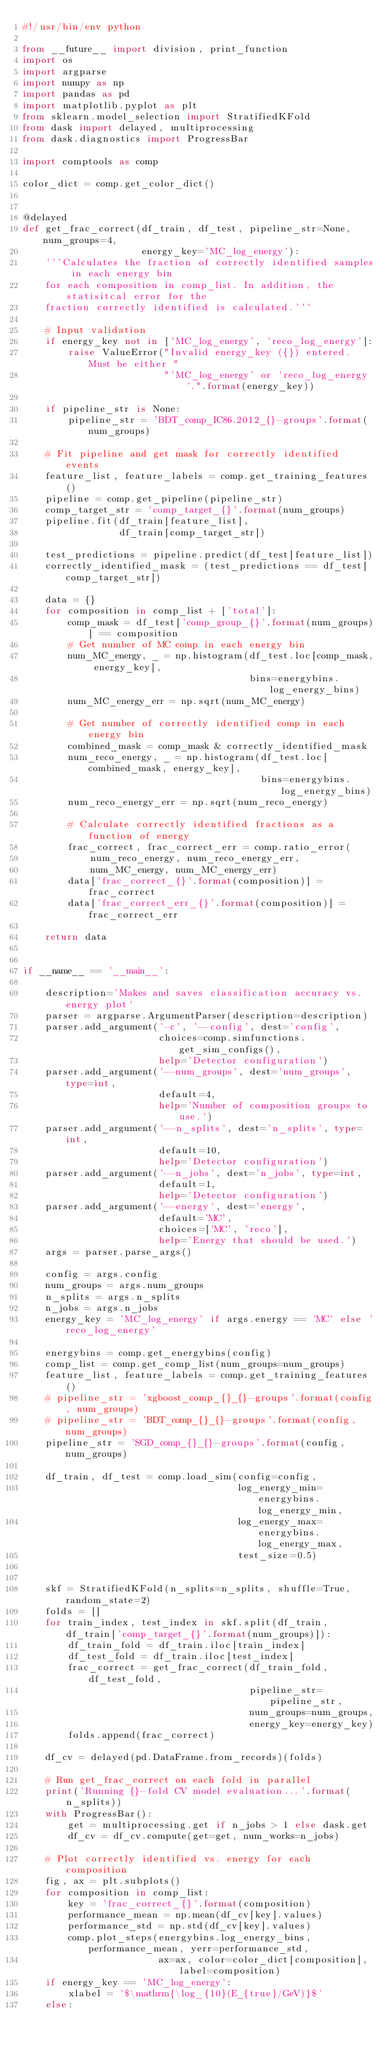<code> <loc_0><loc_0><loc_500><loc_500><_Python_>#!/usr/bin/env python

from __future__ import division, print_function
import os
import argparse
import numpy as np
import pandas as pd
import matplotlib.pyplot as plt
from sklearn.model_selection import StratifiedKFold
from dask import delayed, multiprocessing
from dask.diagnostics import ProgressBar

import comptools as comp

color_dict = comp.get_color_dict()


@delayed
def get_frac_correct(df_train, df_test, pipeline_str=None, num_groups=4,
                     energy_key='MC_log_energy'):
    '''Calculates the fraction of correctly identified samples in each energy bin
    for each composition in comp_list. In addition, the statisitcal error for the
    fraction correctly identified is calculated.'''

    # Input validation
    if energy_key not in ['MC_log_energy', 'reco_log_energy']:
        raise ValueError("Invalid energy_key ({}) entered. Must be either "
                         "'MC_log_energy' or 'reco_log_energy'.".format(energy_key))

    if pipeline_str is None:
        pipeline_str = 'BDT_comp_IC86.2012_{}-groups'.format(num_groups)

    # Fit pipeline and get mask for correctly identified events
    feature_list, feature_labels = comp.get_training_features()
    pipeline = comp.get_pipeline(pipeline_str)
    comp_target_str = 'comp_target_{}'.format(num_groups)
    pipeline.fit(df_train[feature_list],
                 df_train[comp_target_str])

    test_predictions = pipeline.predict(df_test[feature_list])
    correctly_identified_mask = (test_predictions == df_test[comp_target_str])

    data = {}
    for composition in comp_list + ['total']:
        comp_mask = df_test['comp_group_{}'.format(num_groups)] == composition
        # Get number of MC comp in each energy bin
        num_MC_energy, _ = np.histogram(df_test.loc[comp_mask, energy_key],
                                        bins=energybins.log_energy_bins)
        num_MC_energy_err = np.sqrt(num_MC_energy)

        # Get number of correctly identified comp in each energy bin
        combined_mask = comp_mask & correctly_identified_mask
        num_reco_energy, _ = np.histogram(df_test.loc[combined_mask, energy_key],
                                          bins=energybins.log_energy_bins)
        num_reco_energy_err = np.sqrt(num_reco_energy)

        # Calculate correctly identified fractions as a function of energy
        frac_correct, frac_correct_err = comp.ratio_error(
            num_reco_energy, num_reco_energy_err,
            num_MC_energy, num_MC_energy_err)
        data['frac_correct_{}'.format(composition)] = frac_correct
        data['frac_correct_err_{}'.format(composition)] = frac_correct_err

    return data


if __name__ == '__main__':

    description='Makes and saves classification accuracy vs. energy plot'
    parser = argparse.ArgumentParser(description=description)
    parser.add_argument('-c', '--config', dest='config',
                        choices=comp.simfunctions.get_sim_configs(),
                        help='Detector configuration')
    parser.add_argument('--num_groups', dest='num_groups', type=int,
                        default=4,
                        help='Number of composition groups to use.')
    parser.add_argument('--n_splits', dest='n_splits', type=int,
                        default=10,
                        help='Detector configuration')
    parser.add_argument('--n_jobs', dest='n_jobs', type=int,
                        default=1,
                        help='Detector configuration')
    parser.add_argument('--energy', dest='energy',
                        default='MC',
                        choices=['MC', 'reco'],
                        help='Energy that should be used.')
    args = parser.parse_args()

    config = args.config
    num_groups = args.num_groups
    n_splits = args.n_splits
    n_jobs = args.n_jobs
    energy_key = 'MC_log_energy' if args.energy == 'MC' else 'reco_log_energy'

    energybins = comp.get_energybins(config)
    comp_list = comp.get_comp_list(num_groups=num_groups)
    feature_list, feature_labels = comp.get_training_features()
    # pipeline_str = 'xgboost_comp_{}_{}-groups'.format(config, num_groups)
    # pipeline_str = 'BDT_comp_{}_{}-groups'.format(config, num_groups)
    pipeline_str = 'SGD_comp_{}_{}-groups'.format(config, num_groups)

    df_train, df_test = comp.load_sim(config=config,
                                      log_energy_min=energybins.log_energy_min,
                                      log_energy_max=energybins.log_energy_max,
                                      test_size=0.5)


    skf = StratifiedKFold(n_splits=n_splits, shuffle=True, random_state=2)
    folds = []
    for train_index, test_index in skf.split(df_train, df_train['comp_target_{}'.format(num_groups)]):
        df_train_fold = df_train.iloc[train_index]
        df_test_fold = df_train.iloc[test_index]
        frac_correct = get_frac_correct(df_train_fold, df_test_fold,
                                        pipeline_str=pipeline_str,
                                        num_groups=num_groups,
                                        energy_key=energy_key)
        folds.append(frac_correct)

    df_cv = delayed(pd.DataFrame.from_records)(folds)

    # Run get_frac_correct on each fold in parallel
    print('Running {}-fold CV model evaluation...'.format(n_splits))
    with ProgressBar():
        get = multiprocessing.get if n_jobs > 1 else dask.get
        df_cv = df_cv.compute(get=get, num_works=n_jobs)

    # Plot correctly identified vs. energy for each composition
    fig, ax = plt.subplots()
    for composition in comp_list:
        key = 'frac_correct_{}'.format(composition)
        performance_mean = np.mean(df_cv[key].values)
        performance_std = np.std(df_cv[key].values)
        comp.plot_steps(energybins.log_energy_bins, performance_mean, yerr=performance_std,
                        ax=ax, color=color_dict[composition], label=composition)
    if energy_key == 'MC_log_energy':
        xlabel = '$\mathrm{\log_{10}(E_{true}/GeV)}$'
    else:</code> 